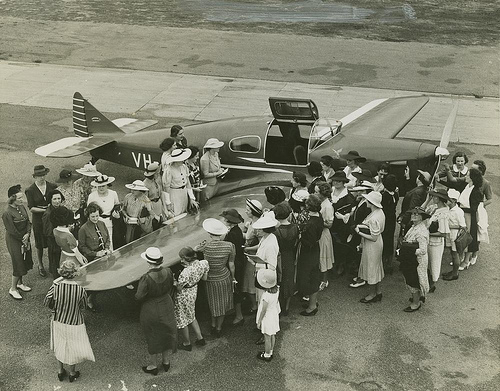How many airplanes are there? 1 